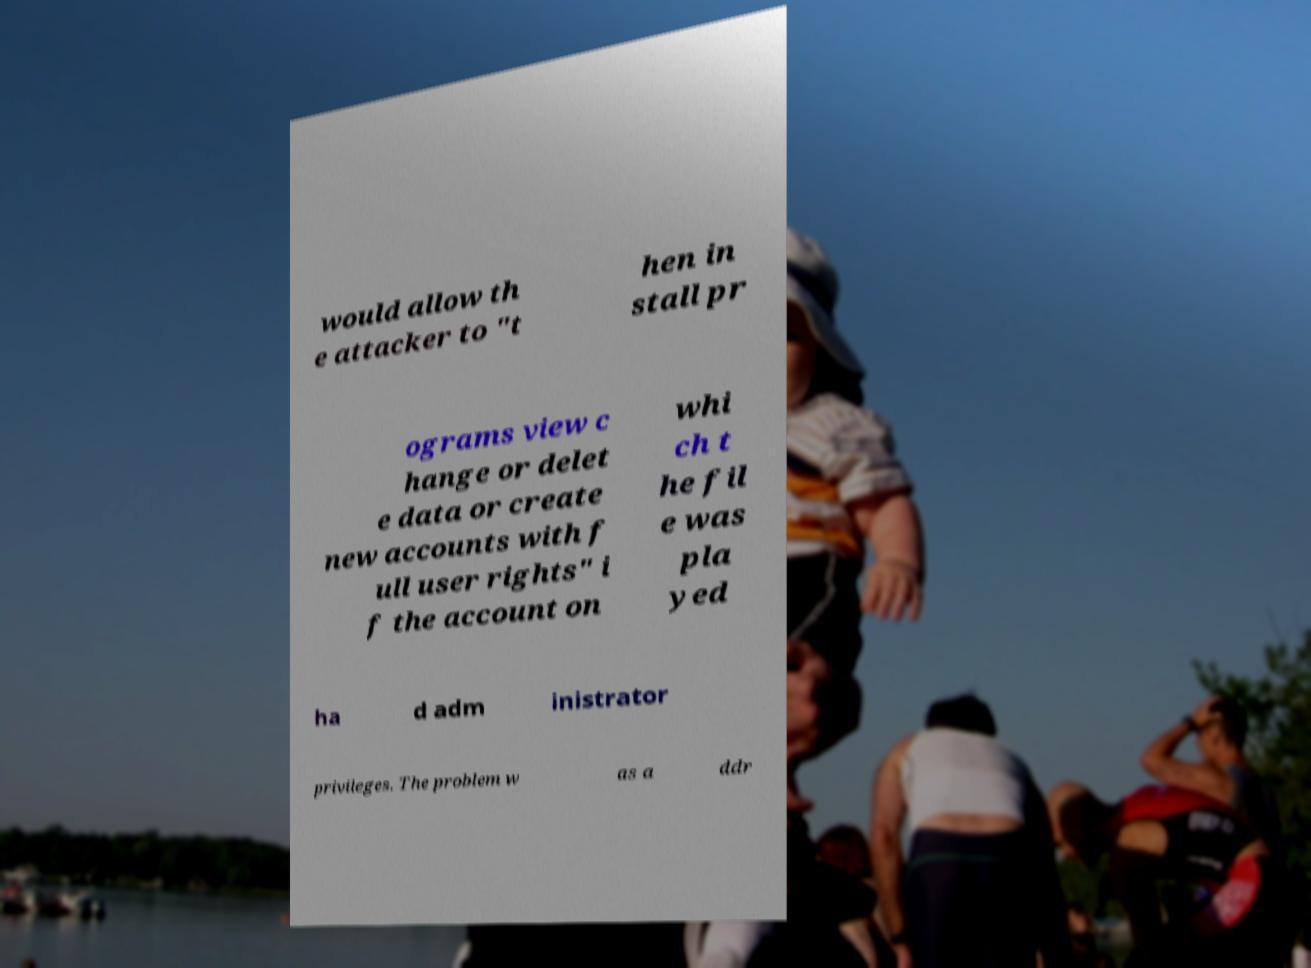Can you read and provide the text displayed in the image?This photo seems to have some interesting text. Can you extract and type it out for me? would allow th e attacker to "t hen in stall pr ograms view c hange or delet e data or create new accounts with f ull user rights" i f the account on whi ch t he fil e was pla yed ha d adm inistrator privileges. The problem w as a ddr 